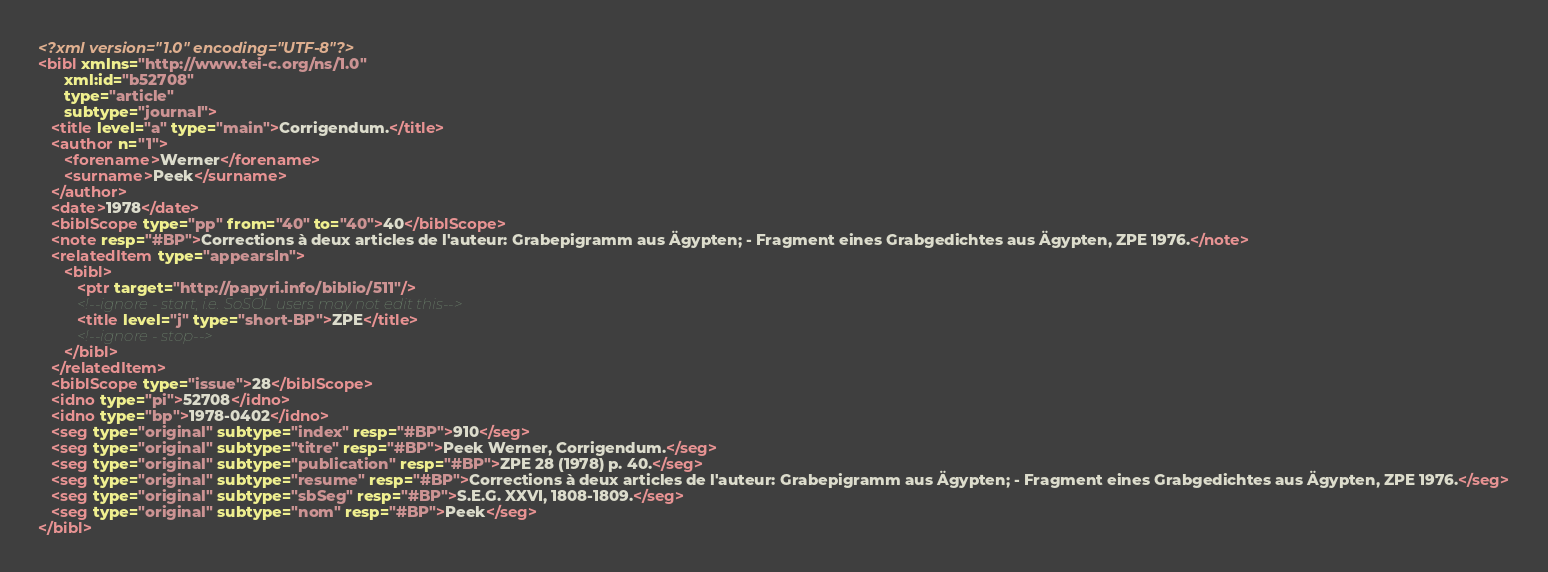<code> <loc_0><loc_0><loc_500><loc_500><_XML_><?xml version="1.0" encoding="UTF-8"?>
<bibl xmlns="http://www.tei-c.org/ns/1.0"
      xml:id="b52708"
      type="article"
      subtype="journal">
   <title level="a" type="main">Corrigendum.</title>
   <author n="1">
      <forename>Werner</forename>
      <surname>Peek</surname>
   </author>
   <date>1978</date>
   <biblScope type="pp" from="40" to="40">40</biblScope>
   <note resp="#BP">Corrections à deux articles de l'auteur: Grabepigramm aus Ägypten; - Fragment eines Grabgedichtes aus Ägypten, ZPE 1976.</note>
   <relatedItem type="appearsIn">
      <bibl>
         <ptr target="http://papyri.info/biblio/511"/>
         <!--ignore - start, i.e. SoSOL users may not edit this-->
         <title level="j" type="short-BP">ZPE</title>
         <!--ignore - stop-->
      </bibl>
   </relatedItem>
   <biblScope type="issue">28</biblScope>
   <idno type="pi">52708</idno>
   <idno type="bp">1978-0402</idno>
   <seg type="original" subtype="index" resp="#BP">910</seg>
   <seg type="original" subtype="titre" resp="#BP">Peek Werner, Corrigendum.</seg>
   <seg type="original" subtype="publication" resp="#BP">ZPE 28 (1978) p. 40.</seg>
   <seg type="original" subtype="resume" resp="#BP">Corrections à deux articles de l'auteur: Grabepigramm aus Ägypten; - Fragment eines Grabgedichtes aus Ägypten, ZPE 1976.</seg>
   <seg type="original" subtype="sbSeg" resp="#BP">S.E.G. XXVI, 1808-1809.</seg>
   <seg type="original" subtype="nom" resp="#BP">Peek</seg>
</bibl>
</code> 